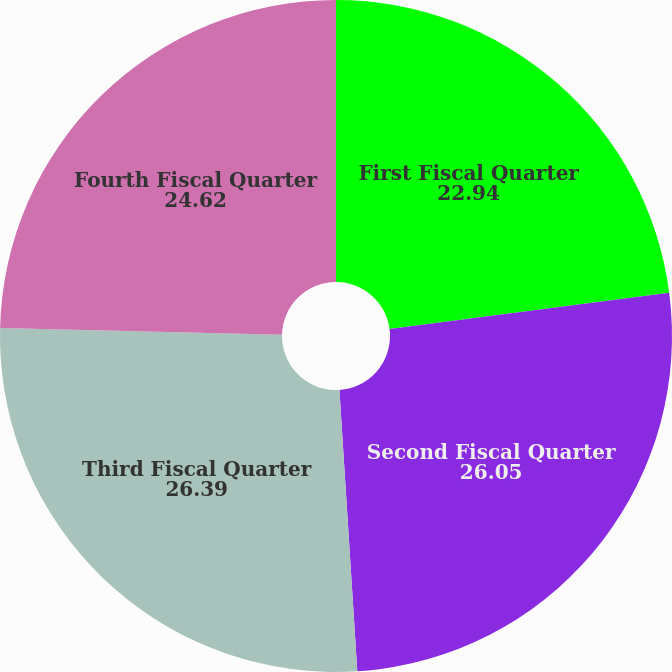Convert chart to OTSL. <chart><loc_0><loc_0><loc_500><loc_500><pie_chart><fcel>First Fiscal Quarter<fcel>Second Fiscal Quarter<fcel>Third Fiscal Quarter<fcel>Fourth Fiscal Quarter<nl><fcel>22.94%<fcel>26.05%<fcel>26.39%<fcel>24.62%<nl></chart> 